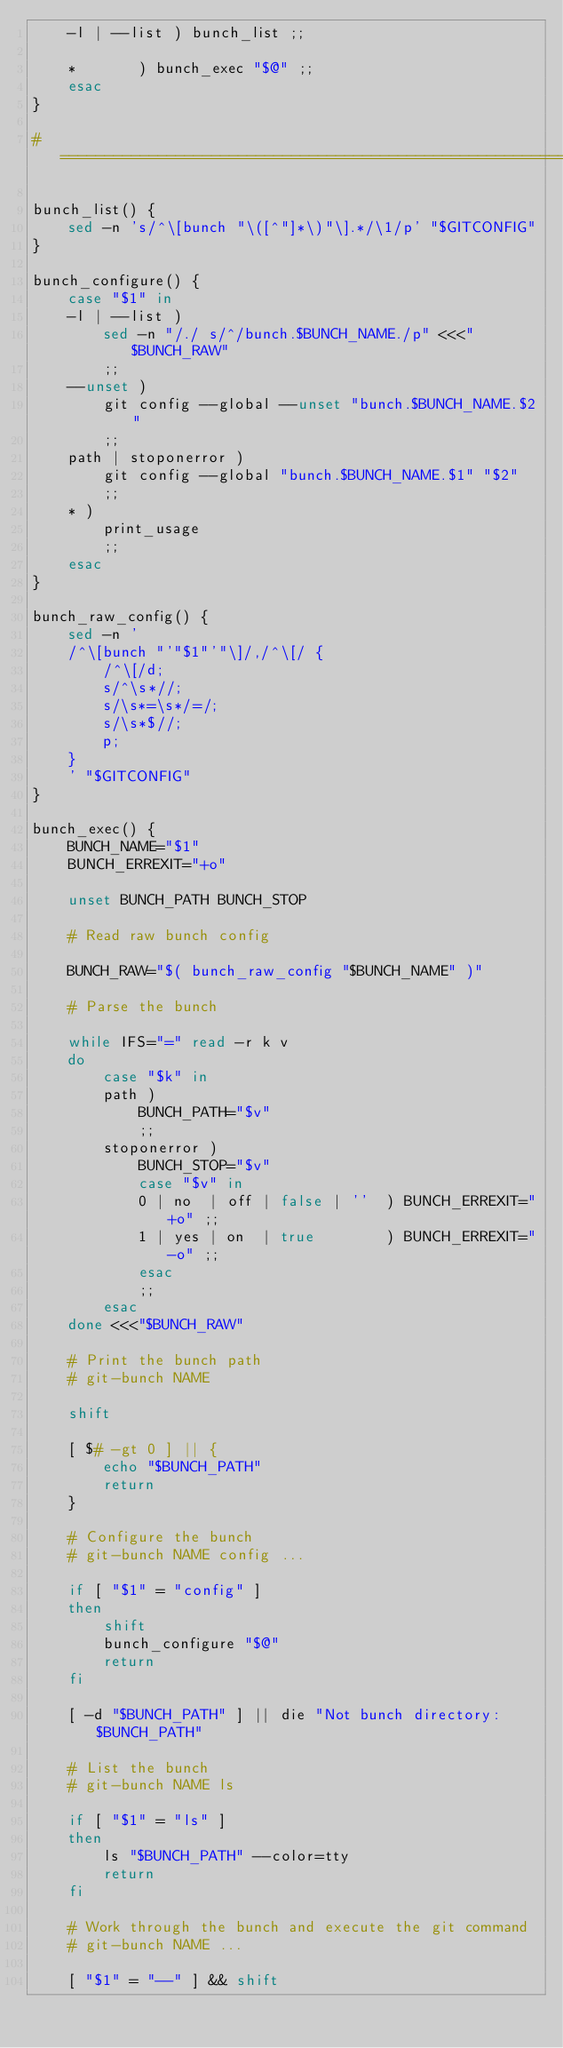Convert code to text. <code><loc_0><loc_0><loc_500><loc_500><_Bash_>	-l | --list	) bunch_list ;;

	* 		) bunch_exec "$@" ;;
	esac
}

# =========================================================================

bunch_list() {
	sed -n 's/^\[bunch "\([^"]*\)"\].*/\1/p' "$GITCONFIG"
}

bunch_configure() {
	case "$1" in
	-l | --list )
		sed -n "/./ s/^/bunch.$BUNCH_NAME./p" <<<"$BUNCH_RAW"
		;;
	--unset )
		git config --global --unset "bunch.$BUNCH_NAME.$2"
		;;
	path | stoponerror )
		git config --global "bunch.$BUNCH_NAME.$1" "$2"
		;;
	* )
		print_usage
		;;
	esac
}

bunch_raw_config() {
	sed -n '
	/^\[bunch "'"$1"'"\]/,/^\[/ {
		/^\[/d;
		s/^\s*//;
		s/\s*=\s*/=/;
		s/\s*$//;
		p;
	}
	' "$GITCONFIG"
}

bunch_exec() {
	BUNCH_NAME="$1"
	BUNCH_ERREXIT="+o"

	unset BUNCH_PATH BUNCH_STOP

	# Read raw bunch config

	BUNCH_RAW="$( bunch_raw_config "$BUNCH_NAME" )"

	# Parse the bunch

	while IFS="=" read -r k v
	do
		case "$k" in
		path )
			BUNCH_PATH="$v"
			;;
		stoponerror )
			BUNCH_STOP="$v"
			case "$v" in
			0 | no  | off | false | ''	) BUNCH_ERREXIT="+o" ;;
			1 | yes | on  | true		) BUNCH_ERREXIT="-o" ;;
			esac
			;;
		esac
	done <<<"$BUNCH_RAW"

	# Print the bunch path
	# git-bunch NAME

	shift

	[ $# -gt 0 ] || {
		echo "$BUNCH_PATH"
		return
	}

	# Configure the bunch
	# git-bunch NAME config ...

	if [ "$1" = "config" ]
	then
		shift
		bunch_configure "$@"
		return
	fi

	[ -d "$BUNCH_PATH" ] || die "Not bunch directory: $BUNCH_PATH"

	# List the bunch
	# git-bunch NAME ls

	if [ "$1" = "ls" ]
	then
		ls "$BUNCH_PATH" --color=tty
		return
	fi

	# Work through the bunch and execute the git command
	# git-bunch NAME ...

	[ "$1" = "--" ] && shift
</code> 